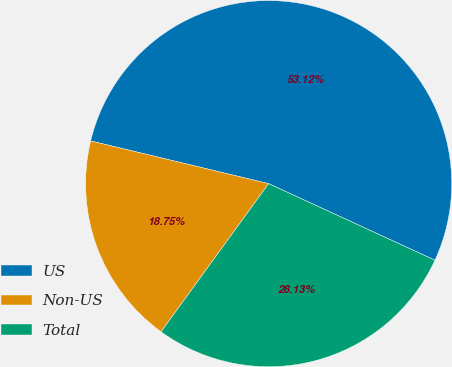<chart> <loc_0><loc_0><loc_500><loc_500><pie_chart><fcel>US<fcel>Non-US<fcel>Total<nl><fcel>53.12%<fcel>18.75%<fcel>28.13%<nl></chart> 